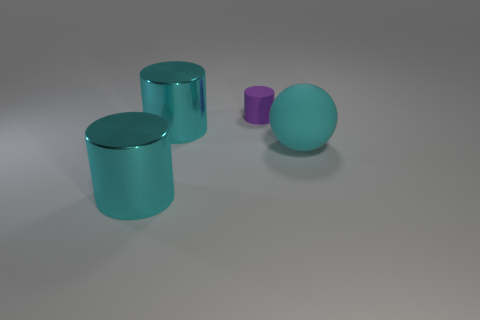Subtract all green balls. How many cyan cylinders are left? 2 Add 2 tiny purple objects. How many objects exist? 6 Subtract all cylinders. How many objects are left? 1 Add 2 big matte objects. How many big matte objects are left? 3 Add 2 big yellow things. How many big yellow things exist? 2 Subtract 1 cyan balls. How many objects are left? 3 Subtract all small purple rubber things. Subtract all purple cylinders. How many objects are left? 2 